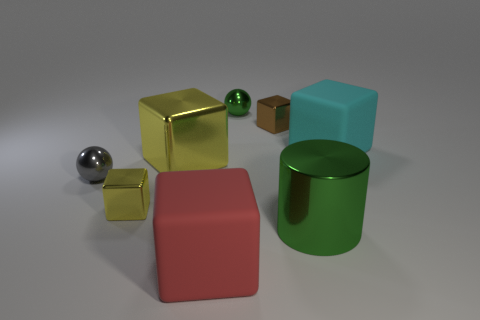What kind of textures do the objects have, and do they seem reflective? The objects display a mixture of textures: the metallic ones (yellow cube, green cylinder, and silver sphere) have shiny, reflective surfaces, while the cubes in red and cyan have a matte, non-reflective texture that suggests a rubbery material. How does the lighting in the image affect our perception of the objects? The lighting highlights the reflective properties of the metallic objects, allowing us to see their sheen and the reflections on their surfaces. It also emphasizes the difference in texture contrasted with the matte objects, which absorb more light and appear evenly lit with soft shadows. 